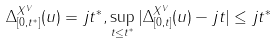Convert formula to latex. <formula><loc_0><loc_0><loc_500><loc_500>\Delta ^ { X ^ { V } } _ { [ 0 , t ^ { * } ] } ( u ) = j t ^ { * } , \sup _ { t \leq t ^ { * } } | \Delta ^ { X ^ { V } } _ { [ 0 , t ] } ( u ) - j t | \leq j t ^ { * }</formula> 